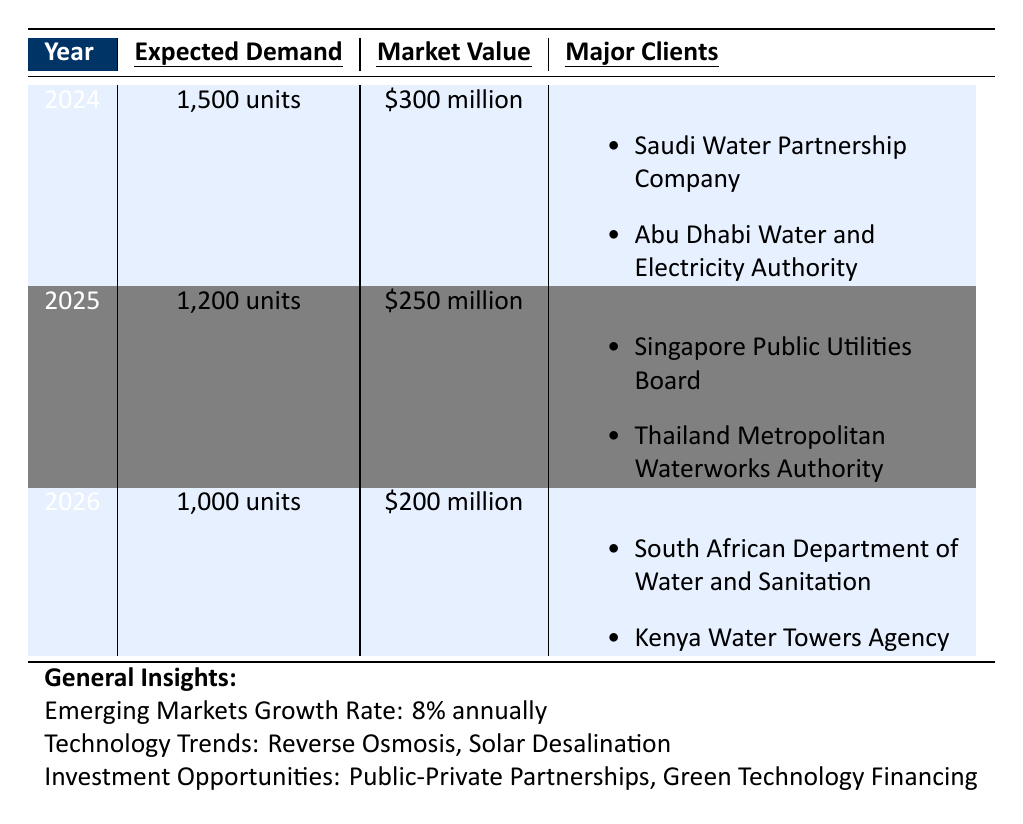What is the expected demand for desalination equipment in 2024? The table lists the expected demand for each year. For 2024, it shows "1,500 units" under the Expected Demand column.
Answer: 1,500 units Which region has the highest market value for desalination equipment in the forecast? The market values for each region in the years are $300 million for 2024, $250 million for 2025, and $200 million for 2026. The highest value is $300 million in 2024.
Answer: Middle East What is the total expected demand for desalination equipment from 2024 to 2026? To find the total expected demand, add the expected demands for each year: 1,500 (2024) + 1,200 (2025) + 1,000 (2026) = 3,700 units.
Answer: 3,700 units Are there any major clients listed for the year 2025? The table shows two major clients listed for 2025: Singapore Public Utilities Board and Thailand Metropolitan Waterworks Authority. Therefore, the answer is yes.
Answer: Yes What is the difference in market value between 2024 and 2026? The market values are $300 million for 2024 and $200 million for 2026. The difference is calculated as $300 million - $200 million = $100 million.
Answer: $100 million Which technology trends are highlighted in the general insights? The table lists two technology trends in the general insights: Reverse Osmosis and Solar Desalination.
Answer: Reverse Osmosis and Solar Desalination Is the emerging markets growth rate above or below 10% annually? The growth rate specified in the general insights is 8% annually, which is below 10%.
Answer: Below 10% If the expected demand increases by the emerging markets growth rate annually, what would be the expected demand for 2025 based on 2024's demand? Based on the growth rate of 8%, the expected demand for 2025 can be calculated by multiplying 2024's demand by 1.08 (1,500 units * 1.08 = 1,620 units). However, the table states it as 1,200 units, indicating an adjustment.
Answer: 1,620 units (adjustment applied) How many major clients are listed for the Sub-Saharan Africa region in 2026? For 2026, the table lists two major clients for the Sub-Saharan Africa region: South African Department of Water and Sanitation and Kenya Water Towers Agency.
Answer: 2 clients What is the average expected demand for desalination equipment over the three forecasted years? The expected demands are 1,500 (2024), 1,200 (2025), and 1,000 (2026). The average is calculated by summing the demands (1,500 + 1,200 + 1,000 = 3,700) and dividing by the number of years (3). Thus, the average is 3,700/3 = 1,233.33 units.
Answer: 1,233.33 units 